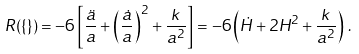Convert formula to latex. <formula><loc_0><loc_0><loc_500><loc_500>R ( \{ \} ) = - 6 \left [ \frac { \ddot { a } } { a } + \left ( \frac { \dot { a } } { a } \right ) ^ { 2 } + \frac { k \, } { a ^ { 2 } } \right ] = - 6 \left ( \dot { H } + 2 H ^ { 2 } + \frac { k \, } { a ^ { 2 } } \right ) \, .</formula> 